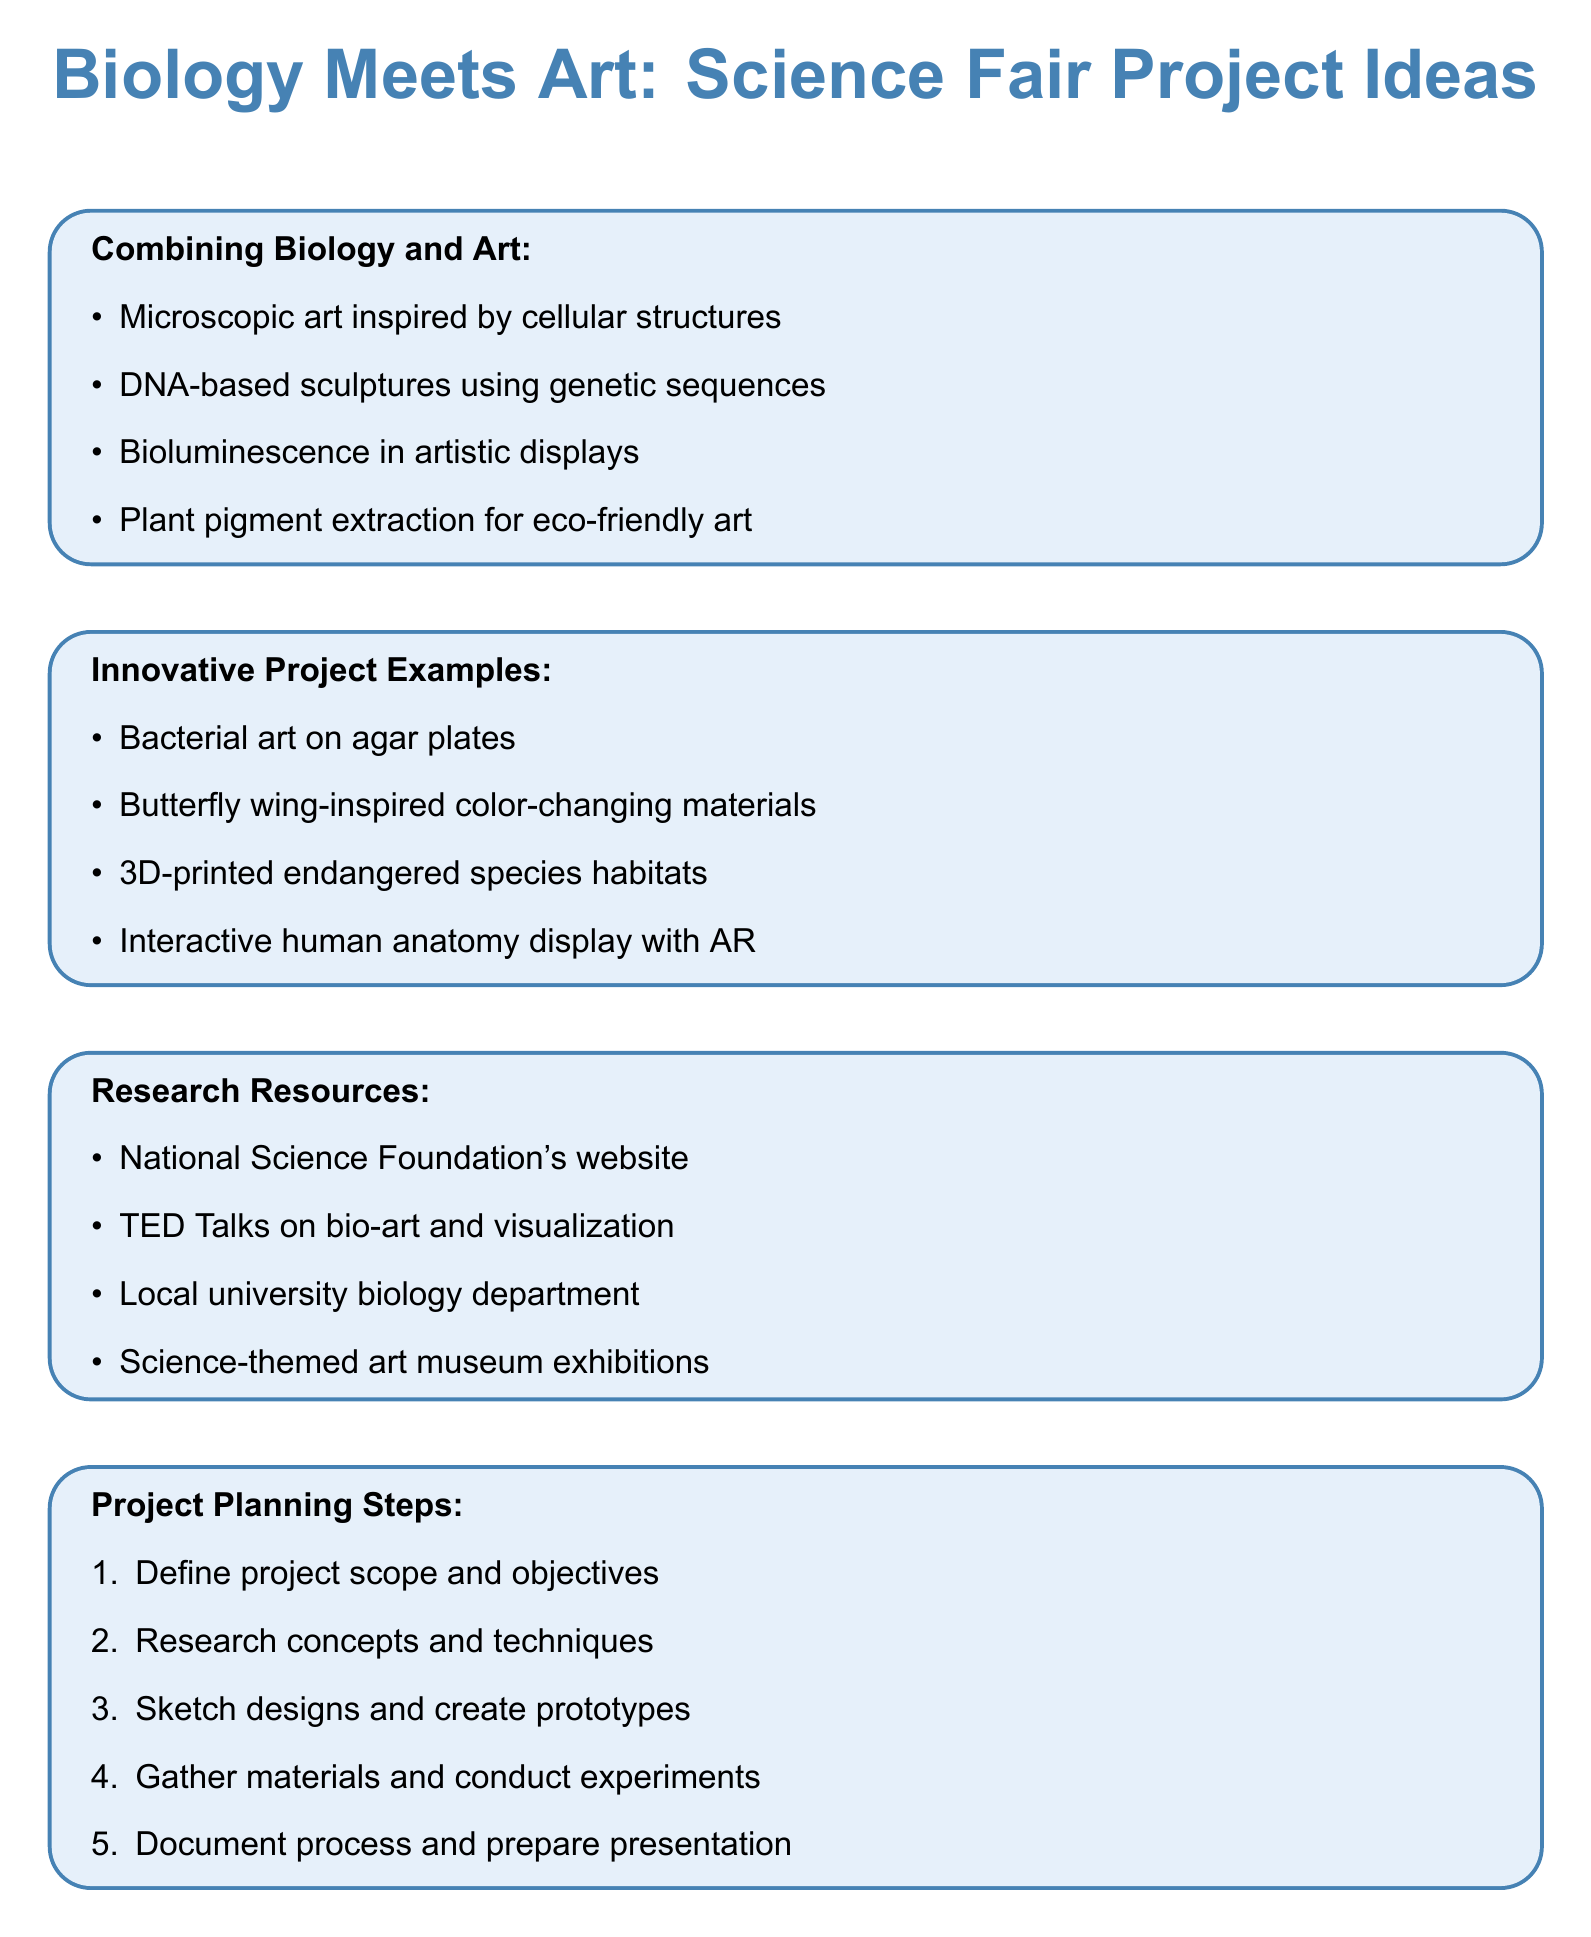What are two examples of combining biology and art? The document lists specific examples of ideas that merge art with biological concepts, including "Microscopic art inspired by cellular structures" and "DNA-based sculptures using genetic sequences."
Answer: Microscopic art, DNA-based sculptures What resource is suggested for mentorship? The document mentions looking to local university biology departments for support and guidance, suggesting it as a helpful resource for students.
Answer: Local university biology department How many steps are in the project planning section? The project planning section provides a list of steps used in preparing a project, specifically outlining five steps.
Answer: 5 What is one potential challenge mentioned regarding the project? Among the potential challenges outlined, one is "Balancing scientific accuracy with artistic expression," indicating a complexity in merging the two fields.
Answer: Balancing scientific accuracy Which artistic display involves organisms that emit light? The document includes "Bioluminescence in art" as a specific example of how light-emitting organisms can be integrated into artistic practices.
Answer: Bioluminescence in art What type of projects does the document suggest for innovative displays? The document includes various innovative project examples, indicating a focus on creative presentations such as "Interactive display of human anatomy using augmented reality."
Answer: Interactive display of human anatomy using augmented reality 